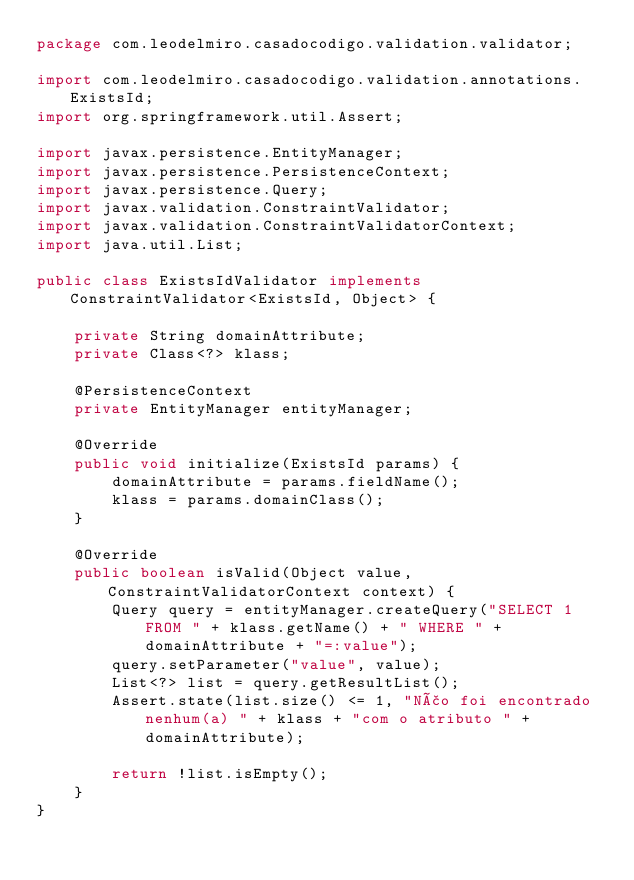<code> <loc_0><loc_0><loc_500><loc_500><_Java_>package com.leodelmiro.casadocodigo.validation.validator;

import com.leodelmiro.casadocodigo.validation.annotations.ExistsId;
import org.springframework.util.Assert;

import javax.persistence.EntityManager;
import javax.persistence.PersistenceContext;
import javax.persistence.Query;
import javax.validation.ConstraintValidator;
import javax.validation.ConstraintValidatorContext;
import java.util.List;

public class ExistsIdValidator implements ConstraintValidator<ExistsId, Object> {

    private String domainAttribute;
    private Class<?> klass;

    @PersistenceContext
    private EntityManager entityManager;

    @Override
    public void initialize(ExistsId params) {
        domainAttribute = params.fieldName();
        klass = params.domainClass();
    }

    @Override
    public boolean isValid(Object value, ConstraintValidatorContext context) {
        Query query = entityManager.createQuery("SELECT 1 FROM " + klass.getName() + " WHERE " + domainAttribute + "=:value");
        query.setParameter("value", value);
        List<?> list = query.getResultList();
        Assert.state(list.size() <= 1, "Não foi encontrado nenhum(a) " + klass + "com o atributo " + domainAttribute);

        return !list.isEmpty();
    }
}
</code> 